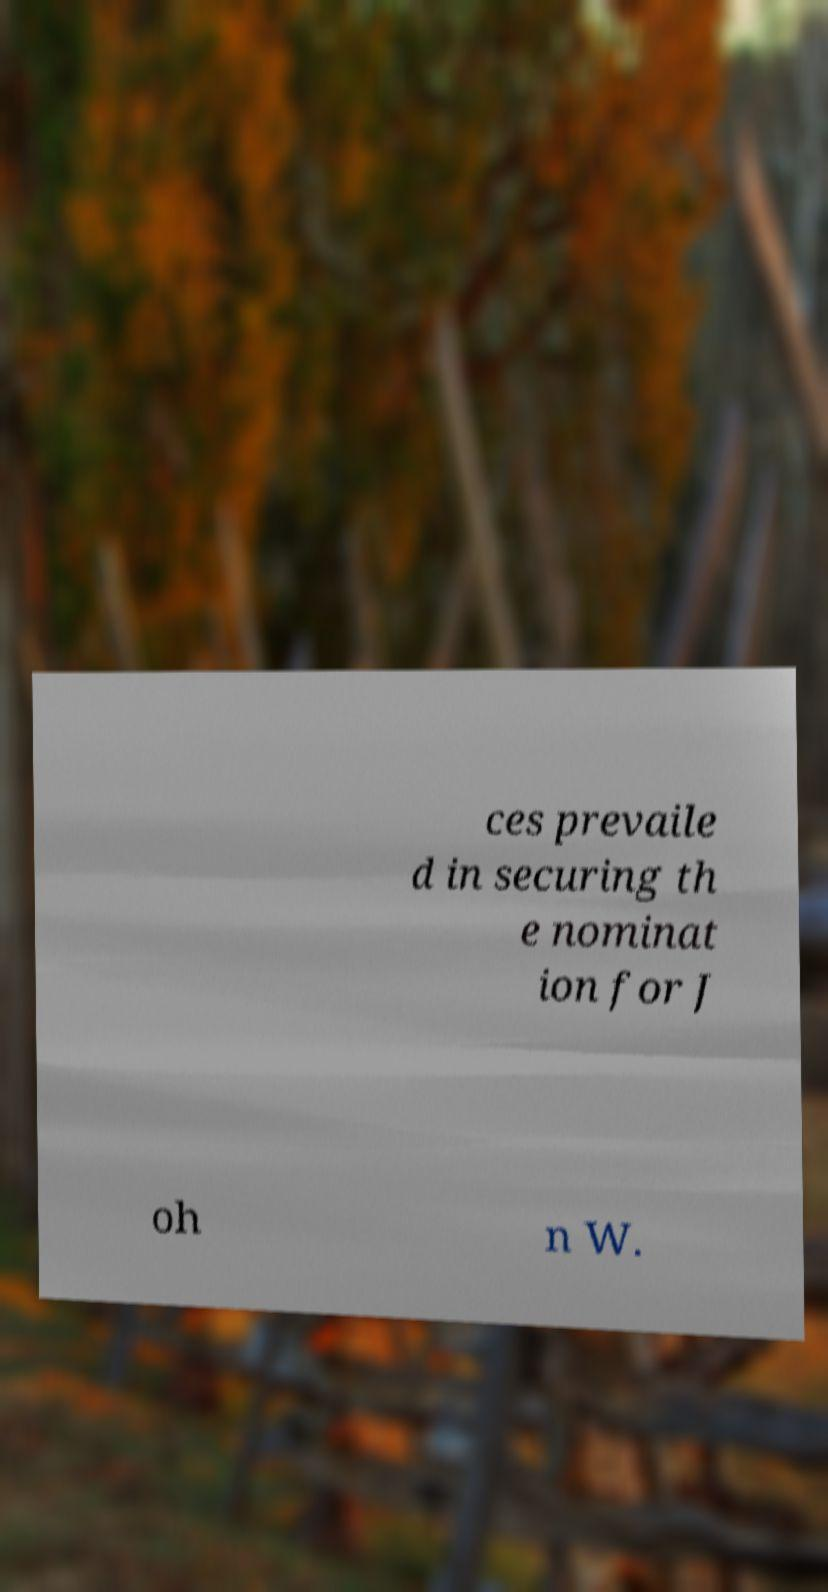Can you accurately transcribe the text from the provided image for me? ces prevaile d in securing th e nominat ion for J oh n W. 